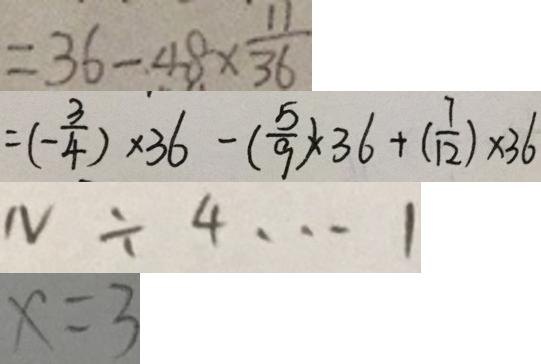<formula> <loc_0><loc_0><loc_500><loc_500>= 3 6 - 4 8 \times \frac { 1 1 } { 3 6 } 
 = ( - \frac { 3 } { 4 } ) \times 3 6 - ( \frac { 5 } { 9 } ) \times 3 6 + ( \frac { 7 } { 1 2 } ) \times 3 6 
 N \div 4 \cdots 1 
 x = 3</formula> 